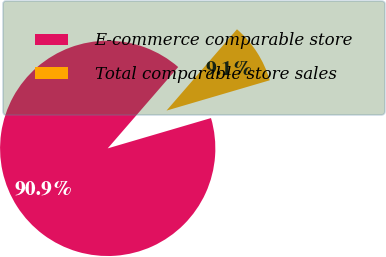<chart> <loc_0><loc_0><loc_500><loc_500><pie_chart><fcel>E-commerce comparable store<fcel>Total comparable store sales<nl><fcel>90.91%<fcel>9.09%<nl></chart> 